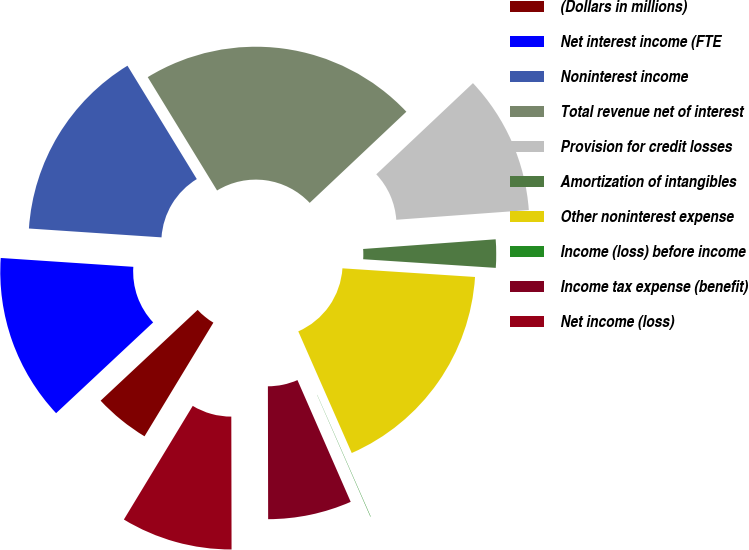Convert chart. <chart><loc_0><loc_0><loc_500><loc_500><pie_chart><fcel>(Dollars in millions)<fcel>Net interest income (FTE<fcel>Noninterest income<fcel>Total revenue net of interest<fcel>Provision for credit losses<fcel>Amortization of intangibles<fcel>Other noninterest expense<fcel>Income (loss) before income<fcel>Income tax expense (benefit)<fcel>Net income (loss)<nl><fcel>4.36%<fcel>13.03%<fcel>15.2%<fcel>21.7%<fcel>10.87%<fcel>2.2%<fcel>17.37%<fcel>0.03%<fcel>6.53%<fcel>8.7%<nl></chart> 